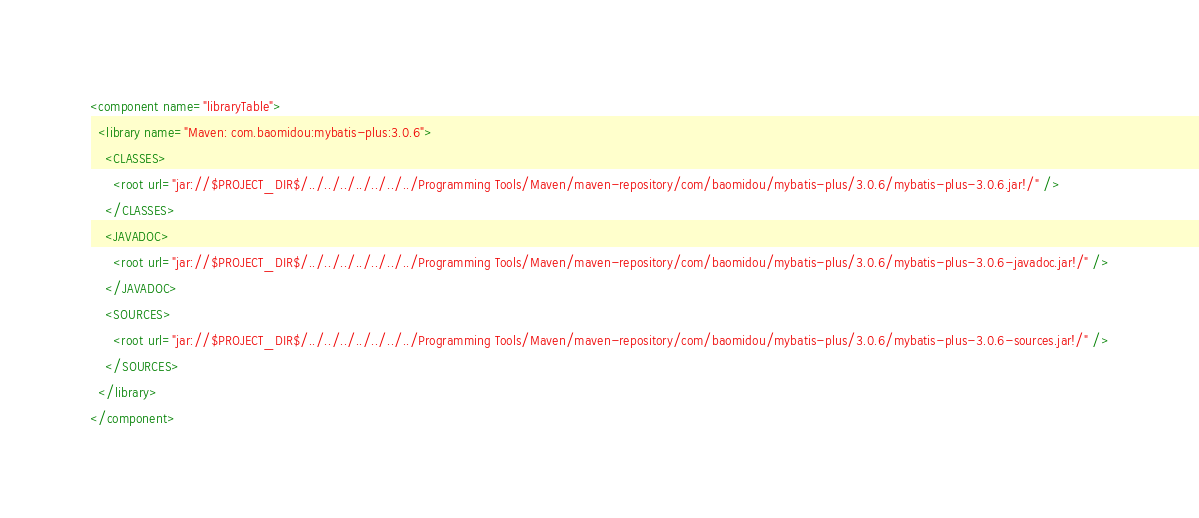Convert code to text. <code><loc_0><loc_0><loc_500><loc_500><_XML_><component name="libraryTable">
  <library name="Maven: com.baomidou:mybatis-plus:3.0.6">
    <CLASSES>
      <root url="jar://$PROJECT_DIR$/../../../../../../../Programming Tools/Maven/maven-repository/com/baomidou/mybatis-plus/3.0.6/mybatis-plus-3.0.6.jar!/" />
    </CLASSES>
    <JAVADOC>
      <root url="jar://$PROJECT_DIR$/../../../../../../../Programming Tools/Maven/maven-repository/com/baomidou/mybatis-plus/3.0.6/mybatis-plus-3.0.6-javadoc.jar!/" />
    </JAVADOC>
    <SOURCES>
      <root url="jar://$PROJECT_DIR$/../../../../../../../Programming Tools/Maven/maven-repository/com/baomidou/mybatis-plus/3.0.6/mybatis-plus-3.0.6-sources.jar!/" />
    </SOURCES>
  </library>
</component></code> 